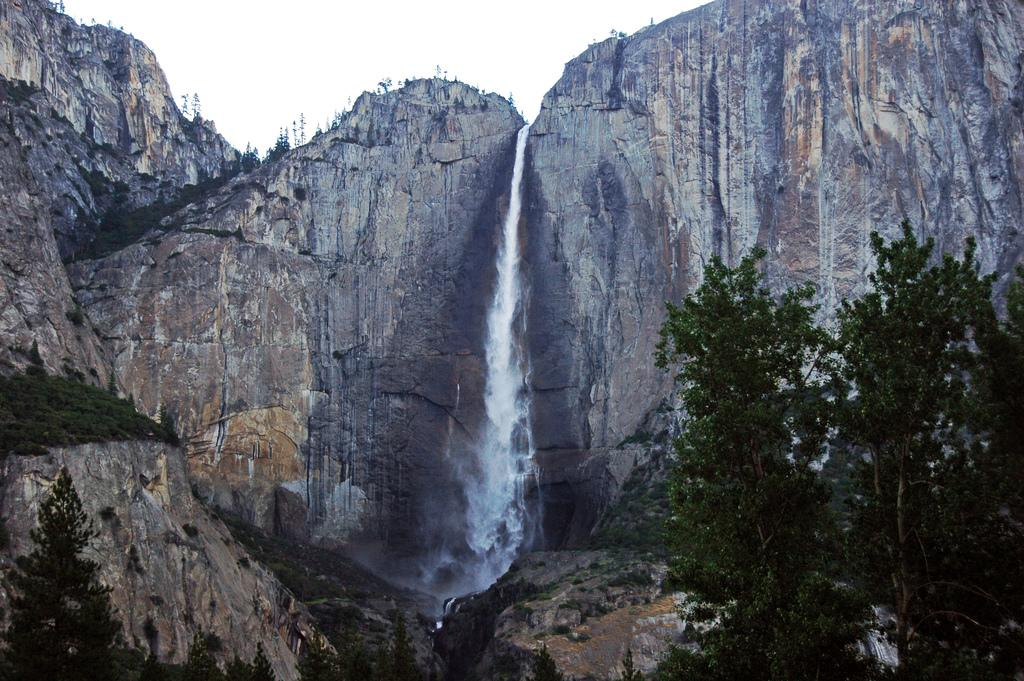What type of natural elements can be seen in the image? There are trees, water, and rocks visible in the image. Can you describe the water in the image? The water is visible in the image, but its specific characteristics are not mentioned in the facts. What type of terrain is depicted in the image? The presence of trees, water, and rocks suggests a natural, outdoor setting. How many legs can be seen supporting the light in the image? There is: There is no light or legs present in the image. 